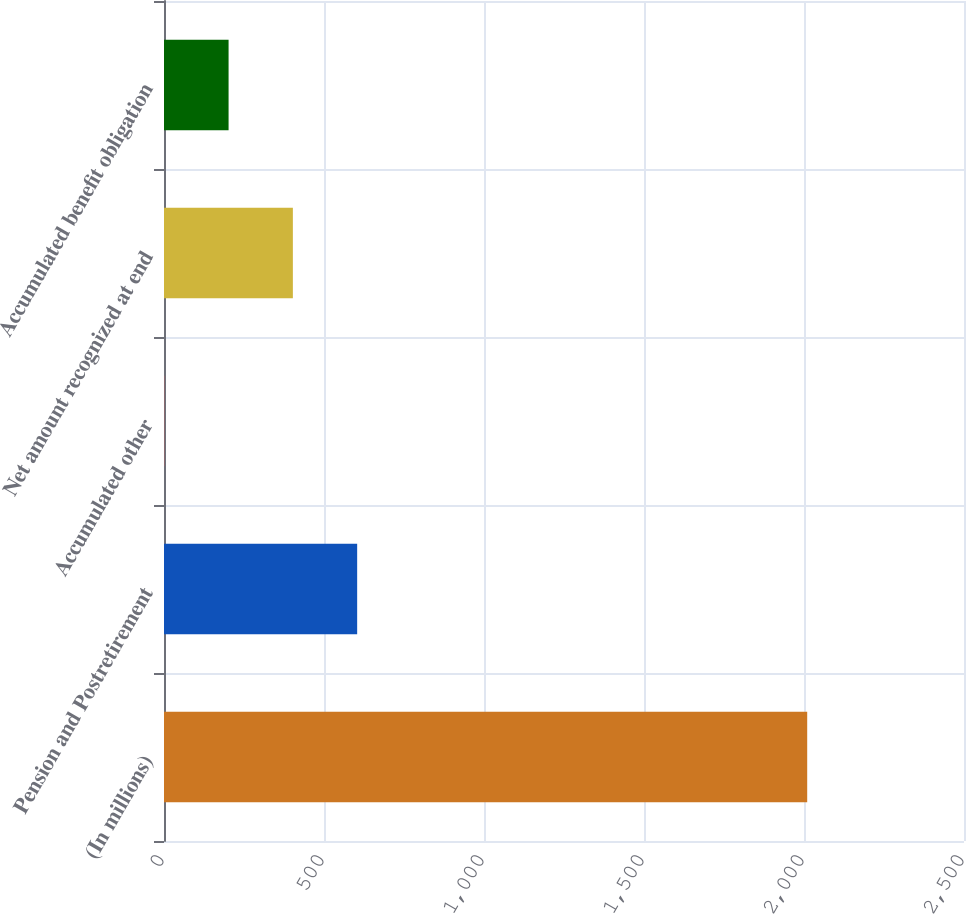<chart> <loc_0><loc_0><loc_500><loc_500><bar_chart><fcel>(In millions)<fcel>Pension and Postretirement<fcel>Accumulated other<fcel>Net amount recognized at end<fcel>Accumulated benefit obligation<nl><fcel>2010<fcel>603.63<fcel>0.9<fcel>402.72<fcel>201.81<nl></chart> 